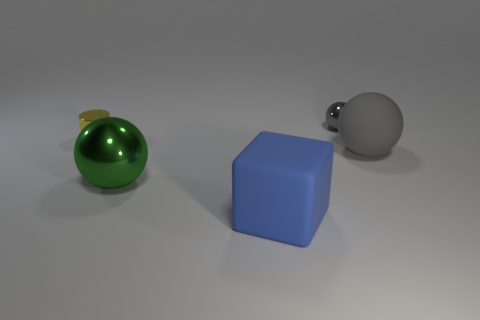There is another ball that is made of the same material as the tiny gray ball; what is its size?
Offer a terse response. Large. Does the cylinder that is in front of the gray shiny ball have the same size as the tiny sphere?
Your response must be concise. Yes. The tiny thing left of the metal object in front of the gray object that is in front of the gray shiny object is what shape?
Your response must be concise. Cylinder. What number of things are cylinders or big objects that are left of the cube?
Ensure brevity in your answer.  2. What is the size of the shiny object that is in front of the yellow object?
Offer a terse response. Large. What shape is the metal thing that is the same color as the big rubber sphere?
Provide a succinct answer. Sphere. Does the yellow object have the same material as the small thing that is right of the big blue thing?
Offer a very short reply. Yes. What number of large blue matte things are on the left side of the small metallic object to the right of the small object to the left of the large blue matte thing?
Make the answer very short. 1. How many gray things are either tiny balls or big metal spheres?
Make the answer very short. 1. What is the shape of the metallic object that is in front of the yellow shiny cylinder?
Make the answer very short. Sphere. 